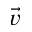Convert formula to latex. <formula><loc_0><loc_0><loc_500><loc_500>\vec { v }</formula> 